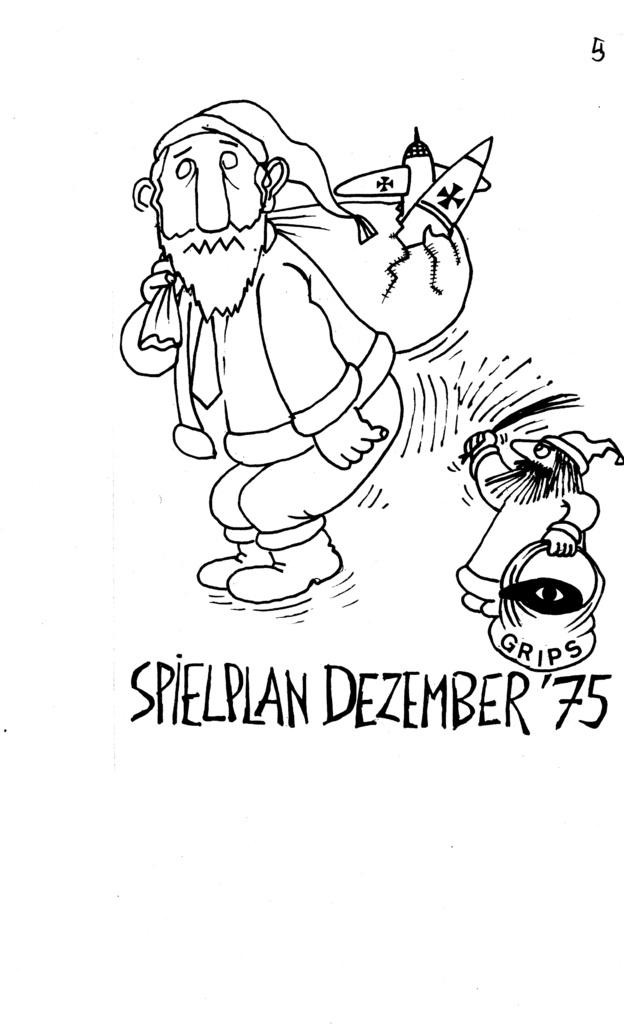What is depicted in the image? There is a sketch of two cartoons in the image. What are the cartoons doing in the sketch? Both cartoons are carrying bags. Is there any text or writing in the image? Yes, there is writing in the image. How many ducks are visible in the image? There are no ducks present in the image; it features a sketch of two cartoons carrying bags. Is there any quicksand in the image? There is no quicksand present in the image. 